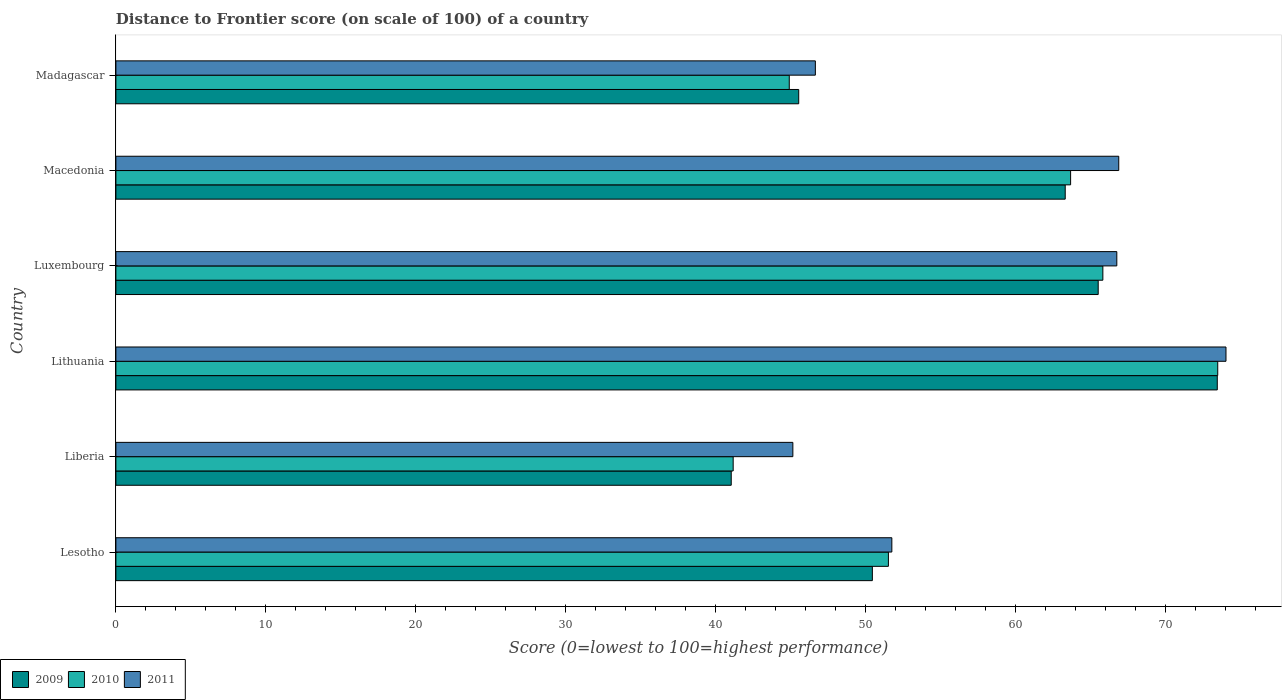Are the number of bars on each tick of the Y-axis equal?
Provide a succinct answer. Yes. What is the label of the 6th group of bars from the top?
Provide a succinct answer. Lesotho. In how many cases, is the number of bars for a given country not equal to the number of legend labels?
Offer a very short reply. 0. What is the distance to frontier score of in 2009 in Luxembourg?
Offer a terse response. 65.5. Across all countries, what is the maximum distance to frontier score of in 2009?
Provide a short and direct response. 73.44. Across all countries, what is the minimum distance to frontier score of in 2010?
Your answer should be very brief. 41.16. In which country was the distance to frontier score of in 2011 maximum?
Provide a short and direct response. Lithuania. In which country was the distance to frontier score of in 2011 minimum?
Ensure brevity in your answer.  Liberia. What is the total distance to frontier score of in 2010 in the graph?
Ensure brevity in your answer.  340.51. What is the difference between the distance to frontier score of in 2010 in Luxembourg and that in Macedonia?
Give a very brief answer. 2.15. What is the difference between the distance to frontier score of in 2009 in Liberia and the distance to frontier score of in 2010 in Madagascar?
Provide a short and direct response. -3.87. What is the average distance to frontier score of in 2010 per country?
Provide a short and direct response. 56.75. What is the difference between the distance to frontier score of in 2010 and distance to frontier score of in 2009 in Luxembourg?
Your answer should be compact. 0.31. In how many countries, is the distance to frontier score of in 2011 greater than 12 ?
Offer a very short reply. 6. What is the ratio of the distance to frontier score of in 2010 in Lesotho to that in Madagascar?
Your answer should be very brief. 1.15. Is the distance to frontier score of in 2011 in Liberia less than that in Lithuania?
Offer a terse response. Yes. Is the difference between the distance to frontier score of in 2010 in Luxembourg and Madagascar greater than the difference between the distance to frontier score of in 2009 in Luxembourg and Madagascar?
Your answer should be compact. Yes. What is the difference between the highest and the second highest distance to frontier score of in 2011?
Your response must be concise. 7.15. What is the difference between the highest and the lowest distance to frontier score of in 2011?
Offer a terse response. 28.88. In how many countries, is the distance to frontier score of in 2011 greater than the average distance to frontier score of in 2011 taken over all countries?
Your answer should be very brief. 3. Is the sum of the distance to frontier score of in 2011 in Liberia and Madagascar greater than the maximum distance to frontier score of in 2009 across all countries?
Make the answer very short. Yes. What does the 2nd bar from the bottom in Lesotho represents?
Provide a succinct answer. 2010. Is it the case that in every country, the sum of the distance to frontier score of in 2010 and distance to frontier score of in 2009 is greater than the distance to frontier score of in 2011?
Your answer should be very brief. Yes. How many bars are there?
Your response must be concise. 18. Are all the bars in the graph horizontal?
Offer a very short reply. Yes. How many countries are there in the graph?
Your answer should be very brief. 6. What is the difference between two consecutive major ticks on the X-axis?
Provide a short and direct response. 10. Are the values on the major ticks of X-axis written in scientific E-notation?
Ensure brevity in your answer.  No. Does the graph contain any zero values?
Your answer should be compact. No. How many legend labels are there?
Provide a short and direct response. 3. What is the title of the graph?
Offer a terse response. Distance to Frontier score (on scale of 100) of a country. What is the label or title of the X-axis?
Your answer should be compact. Score (0=lowest to 100=highest performance). What is the Score (0=lowest to 100=highest performance) of 2009 in Lesotho?
Your answer should be very brief. 50.44. What is the Score (0=lowest to 100=highest performance) of 2010 in Lesotho?
Offer a very short reply. 51.51. What is the Score (0=lowest to 100=highest performance) in 2011 in Lesotho?
Provide a short and direct response. 51.74. What is the Score (0=lowest to 100=highest performance) of 2009 in Liberia?
Give a very brief answer. 41.03. What is the Score (0=lowest to 100=highest performance) in 2010 in Liberia?
Provide a short and direct response. 41.16. What is the Score (0=lowest to 100=highest performance) in 2011 in Liberia?
Offer a terse response. 45.14. What is the Score (0=lowest to 100=highest performance) of 2009 in Lithuania?
Your response must be concise. 73.44. What is the Score (0=lowest to 100=highest performance) in 2010 in Lithuania?
Provide a short and direct response. 73.47. What is the Score (0=lowest to 100=highest performance) of 2011 in Lithuania?
Keep it short and to the point. 74.02. What is the Score (0=lowest to 100=highest performance) in 2009 in Luxembourg?
Provide a short and direct response. 65.5. What is the Score (0=lowest to 100=highest performance) in 2010 in Luxembourg?
Offer a very short reply. 65.81. What is the Score (0=lowest to 100=highest performance) of 2011 in Luxembourg?
Provide a short and direct response. 66.74. What is the Score (0=lowest to 100=highest performance) of 2009 in Macedonia?
Make the answer very short. 63.3. What is the Score (0=lowest to 100=highest performance) in 2010 in Macedonia?
Provide a succinct answer. 63.66. What is the Score (0=lowest to 100=highest performance) of 2011 in Macedonia?
Your answer should be very brief. 66.87. What is the Score (0=lowest to 100=highest performance) in 2009 in Madagascar?
Your answer should be compact. 45.53. What is the Score (0=lowest to 100=highest performance) in 2010 in Madagascar?
Offer a very short reply. 44.9. What is the Score (0=lowest to 100=highest performance) in 2011 in Madagascar?
Provide a succinct answer. 46.64. Across all countries, what is the maximum Score (0=lowest to 100=highest performance) of 2009?
Offer a very short reply. 73.44. Across all countries, what is the maximum Score (0=lowest to 100=highest performance) in 2010?
Offer a very short reply. 73.47. Across all countries, what is the maximum Score (0=lowest to 100=highest performance) in 2011?
Offer a terse response. 74.02. Across all countries, what is the minimum Score (0=lowest to 100=highest performance) in 2009?
Your answer should be very brief. 41.03. Across all countries, what is the minimum Score (0=lowest to 100=highest performance) in 2010?
Offer a very short reply. 41.16. Across all countries, what is the minimum Score (0=lowest to 100=highest performance) of 2011?
Your answer should be compact. 45.14. What is the total Score (0=lowest to 100=highest performance) in 2009 in the graph?
Your response must be concise. 339.24. What is the total Score (0=lowest to 100=highest performance) of 2010 in the graph?
Offer a terse response. 340.51. What is the total Score (0=lowest to 100=highest performance) of 2011 in the graph?
Give a very brief answer. 351.15. What is the difference between the Score (0=lowest to 100=highest performance) of 2009 in Lesotho and that in Liberia?
Offer a terse response. 9.41. What is the difference between the Score (0=lowest to 100=highest performance) in 2010 in Lesotho and that in Liberia?
Make the answer very short. 10.35. What is the difference between the Score (0=lowest to 100=highest performance) of 2011 in Lesotho and that in Liberia?
Keep it short and to the point. 6.6. What is the difference between the Score (0=lowest to 100=highest performance) in 2010 in Lesotho and that in Lithuania?
Your response must be concise. -21.96. What is the difference between the Score (0=lowest to 100=highest performance) in 2011 in Lesotho and that in Lithuania?
Provide a short and direct response. -22.28. What is the difference between the Score (0=lowest to 100=highest performance) of 2009 in Lesotho and that in Luxembourg?
Your answer should be compact. -15.06. What is the difference between the Score (0=lowest to 100=highest performance) of 2010 in Lesotho and that in Luxembourg?
Give a very brief answer. -14.3. What is the difference between the Score (0=lowest to 100=highest performance) in 2009 in Lesotho and that in Macedonia?
Your answer should be compact. -12.86. What is the difference between the Score (0=lowest to 100=highest performance) in 2010 in Lesotho and that in Macedonia?
Your answer should be compact. -12.15. What is the difference between the Score (0=lowest to 100=highest performance) in 2011 in Lesotho and that in Macedonia?
Make the answer very short. -15.13. What is the difference between the Score (0=lowest to 100=highest performance) of 2009 in Lesotho and that in Madagascar?
Ensure brevity in your answer.  4.91. What is the difference between the Score (0=lowest to 100=highest performance) in 2010 in Lesotho and that in Madagascar?
Ensure brevity in your answer.  6.61. What is the difference between the Score (0=lowest to 100=highest performance) in 2011 in Lesotho and that in Madagascar?
Ensure brevity in your answer.  5.1. What is the difference between the Score (0=lowest to 100=highest performance) of 2009 in Liberia and that in Lithuania?
Provide a short and direct response. -32.41. What is the difference between the Score (0=lowest to 100=highest performance) of 2010 in Liberia and that in Lithuania?
Keep it short and to the point. -32.31. What is the difference between the Score (0=lowest to 100=highest performance) in 2011 in Liberia and that in Lithuania?
Keep it short and to the point. -28.88. What is the difference between the Score (0=lowest to 100=highest performance) of 2009 in Liberia and that in Luxembourg?
Your answer should be compact. -24.47. What is the difference between the Score (0=lowest to 100=highest performance) in 2010 in Liberia and that in Luxembourg?
Make the answer very short. -24.65. What is the difference between the Score (0=lowest to 100=highest performance) of 2011 in Liberia and that in Luxembourg?
Provide a succinct answer. -21.6. What is the difference between the Score (0=lowest to 100=highest performance) of 2009 in Liberia and that in Macedonia?
Your answer should be very brief. -22.27. What is the difference between the Score (0=lowest to 100=highest performance) of 2010 in Liberia and that in Macedonia?
Offer a very short reply. -22.5. What is the difference between the Score (0=lowest to 100=highest performance) in 2011 in Liberia and that in Macedonia?
Offer a terse response. -21.73. What is the difference between the Score (0=lowest to 100=highest performance) of 2010 in Liberia and that in Madagascar?
Ensure brevity in your answer.  -3.74. What is the difference between the Score (0=lowest to 100=highest performance) of 2011 in Liberia and that in Madagascar?
Your response must be concise. -1.5. What is the difference between the Score (0=lowest to 100=highest performance) in 2009 in Lithuania and that in Luxembourg?
Give a very brief answer. 7.94. What is the difference between the Score (0=lowest to 100=highest performance) of 2010 in Lithuania and that in Luxembourg?
Keep it short and to the point. 7.66. What is the difference between the Score (0=lowest to 100=highest performance) in 2011 in Lithuania and that in Luxembourg?
Ensure brevity in your answer.  7.28. What is the difference between the Score (0=lowest to 100=highest performance) in 2009 in Lithuania and that in Macedonia?
Your answer should be compact. 10.14. What is the difference between the Score (0=lowest to 100=highest performance) of 2010 in Lithuania and that in Macedonia?
Ensure brevity in your answer.  9.81. What is the difference between the Score (0=lowest to 100=highest performance) in 2011 in Lithuania and that in Macedonia?
Your answer should be compact. 7.15. What is the difference between the Score (0=lowest to 100=highest performance) of 2009 in Lithuania and that in Madagascar?
Provide a short and direct response. 27.91. What is the difference between the Score (0=lowest to 100=highest performance) of 2010 in Lithuania and that in Madagascar?
Give a very brief answer. 28.57. What is the difference between the Score (0=lowest to 100=highest performance) of 2011 in Lithuania and that in Madagascar?
Keep it short and to the point. 27.38. What is the difference between the Score (0=lowest to 100=highest performance) in 2010 in Luxembourg and that in Macedonia?
Your response must be concise. 2.15. What is the difference between the Score (0=lowest to 100=highest performance) in 2011 in Luxembourg and that in Macedonia?
Ensure brevity in your answer.  -0.13. What is the difference between the Score (0=lowest to 100=highest performance) in 2009 in Luxembourg and that in Madagascar?
Your response must be concise. 19.97. What is the difference between the Score (0=lowest to 100=highest performance) of 2010 in Luxembourg and that in Madagascar?
Provide a short and direct response. 20.91. What is the difference between the Score (0=lowest to 100=highest performance) of 2011 in Luxembourg and that in Madagascar?
Ensure brevity in your answer.  20.1. What is the difference between the Score (0=lowest to 100=highest performance) of 2009 in Macedonia and that in Madagascar?
Give a very brief answer. 17.77. What is the difference between the Score (0=lowest to 100=highest performance) in 2010 in Macedonia and that in Madagascar?
Give a very brief answer. 18.76. What is the difference between the Score (0=lowest to 100=highest performance) of 2011 in Macedonia and that in Madagascar?
Your answer should be very brief. 20.23. What is the difference between the Score (0=lowest to 100=highest performance) of 2009 in Lesotho and the Score (0=lowest to 100=highest performance) of 2010 in Liberia?
Ensure brevity in your answer.  9.28. What is the difference between the Score (0=lowest to 100=highest performance) of 2010 in Lesotho and the Score (0=lowest to 100=highest performance) of 2011 in Liberia?
Offer a terse response. 6.37. What is the difference between the Score (0=lowest to 100=highest performance) of 2009 in Lesotho and the Score (0=lowest to 100=highest performance) of 2010 in Lithuania?
Provide a short and direct response. -23.03. What is the difference between the Score (0=lowest to 100=highest performance) of 2009 in Lesotho and the Score (0=lowest to 100=highest performance) of 2011 in Lithuania?
Offer a very short reply. -23.58. What is the difference between the Score (0=lowest to 100=highest performance) in 2010 in Lesotho and the Score (0=lowest to 100=highest performance) in 2011 in Lithuania?
Your answer should be compact. -22.51. What is the difference between the Score (0=lowest to 100=highest performance) in 2009 in Lesotho and the Score (0=lowest to 100=highest performance) in 2010 in Luxembourg?
Your answer should be very brief. -15.37. What is the difference between the Score (0=lowest to 100=highest performance) of 2009 in Lesotho and the Score (0=lowest to 100=highest performance) of 2011 in Luxembourg?
Give a very brief answer. -16.3. What is the difference between the Score (0=lowest to 100=highest performance) of 2010 in Lesotho and the Score (0=lowest to 100=highest performance) of 2011 in Luxembourg?
Your answer should be very brief. -15.23. What is the difference between the Score (0=lowest to 100=highest performance) in 2009 in Lesotho and the Score (0=lowest to 100=highest performance) in 2010 in Macedonia?
Your answer should be compact. -13.22. What is the difference between the Score (0=lowest to 100=highest performance) of 2009 in Lesotho and the Score (0=lowest to 100=highest performance) of 2011 in Macedonia?
Your answer should be compact. -16.43. What is the difference between the Score (0=lowest to 100=highest performance) of 2010 in Lesotho and the Score (0=lowest to 100=highest performance) of 2011 in Macedonia?
Your answer should be compact. -15.36. What is the difference between the Score (0=lowest to 100=highest performance) in 2009 in Lesotho and the Score (0=lowest to 100=highest performance) in 2010 in Madagascar?
Make the answer very short. 5.54. What is the difference between the Score (0=lowest to 100=highest performance) in 2010 in Lesotho and the Score (0=lowest to 100=highest performance) in 2011 in Madagascar?
Your answer should be very brief. 4.87. What is the difference between the Score (0=lowest to 100=highest performance) in 2009 in Liberia and the Score (0=lowest to 100=highest performance) in 2010 in Lithuania?
Offer a very short reply. -32.44. What is the difference between the Score (0=lowest to 100=highest performance) of 2009 in Liberia and the Score (0=lowest to 100=highest performance) of 2011 in Lithuania?
Keep it short and to the point. -32.99. What is the difference between the Score (0=lowest to 100=highest performance) in 2010 in Liberia and the Score (0=lowest to 100=highest performance) in 2011 in Lithuania?
Your response must be concise. -32.86. What is the difference between the Score (0=lowest to 100=highest performance) of 2009 in Liberia and the Score (0=lowest to 100=highest performance) of 2010 in Luxembourg?
Your response must be concise. -24.78. What is the difference between the Score (0=lowest to 100=highest performance) in 2009 in Liberia and the Score (0=lowest to 100=highest performance) in 2011 in Luxembourg?
Your response must be concise. -25.71. What is the difference between the Score (0=lowest to 100=highest performance) of 2010 in Liberia and the Score (0=lowest to 100=highest performance) of 2011 in Luxembourg?
Give a very brief answer. -25.58. What is the difference between the Score (0=lowest to 100=highest performance) of 2009 in Liberia and the Score (0=lowest to 100=highest performance) of 2010 in Macedonia?
Provide a succinct answer. -22.63. What is the difference between the Score (0=lowest to 100=highest performance) in 2009 in Liberia and the Score (0=lowest to 100=highest performance) in 2011 in Macedonia?
Make the answer very short. -25.84. What is the difference between the Score (0=lowest to 100=highest performance) in 2010 in Liberia and the Score (0=lowest to 100=highest performance) in 2011 in Macedonia?
Make the answer very short. -25.71. What is the difference between the Score (0=lowest to 100=highest performance) in 2009 in Liberia and the Score (0=lowest to 100=highest performance) in 2010 in Madagascar?
Offer a terse response. -3.87. What is the difference between the Score (0=lowest to 100=highest performance) of 2009 in Liberia and the Score (0=lowest to 100=highest performance) of 2011 in Madagascar?
Your response must be concise. -5.61. What is the difference between the Score (0=lowest to 100=highest performance) of 2010 in Liberia and the Score (0=lowest to 100=highest performance) of 2011 in Madagascar?
Offer a terse response. -5.48. What is the difference between the Score (0=lowest to 100=highest performance) of 2009 in Lithuania and the Score (0=lowest to 100=highest performance) of 2010 in Luxembourg?
Provide a short and direct response. 7.63. What is the difference between the Score (0=lowest to 100=highest performance) of 2009 in Lithuania and the Score (0=lowest to 100=highest performance) of 2011 in Luxembourg?
Keep it short and to the point. 6.7. What is the difference between the Score (0=lowest to 100=highest performance) in 2010 in Lithuania and the Score (0=lowest to 100=highest performance) in 2011 in Luxembourg?
Your answer should be compact. 6.73. What is the difference between the Score (0=lowest to 100=highest performance) in 2009 in Lithuania and the Score (0=lowest to 100=highest performance) in 2010 in Macedonia?
Your answer should be compact. 9.78. What is the difference between the Score (0=lowest to 100=highest performance) of 2009 in Lithuania and the Score (0=lowest to 100=highest performance) of 2011 in Macedonia?
Ensure brevity in your answer.  6.57. What is the difference between the Score (0=lowest to 100=highest performance) of 2009 in Lithuania and the Score (0=lowest to 100=highest performance) of 2010 in Madagascar?
Make the answer very short. 28.54. What is the difference between the Score (0=lowest to 100=highest performance) in 2009 in Lithuania and the Score (0=lowest to 100=highest performance) in 2011 in Madagascar?
Your answer should be compact. 26.8. What is the difference between the Score (0=lowest to 100=highest performance) in 2010 in Lithuania and the Score (0=lowest to 100=highest performance) in 2011 in Madagascar?
Offer a terse response. 26.83. What is the difference between the Score (0=lowest to 100=highest performance) of 2009 in Luxembourg and the Score (0=lowest to 100=highest performance) of 2010 in Macedonia?
Keep it short and to the point. 1.84. What is the difference between the Score (0=lowest to 100=highest performance) in 2009 in Luxembourg and the Score (0=lowest to 100=highest performance) in 2011 in Macedonia?
Keep it short and to the point. -1.37. What is the difference between the Score (0=lowest to 100=highest performance) of 2010 in Luxembourg and the Score (0=lowest to 100=highest performance) of 2011 in Macedonia?
Offer a very short reply. -1.06. What is the difference between the Score (0=lowest to 100=highest performance) of 2009 in Luxembourg and the Score (0=lowest to 100=highest performance) of 2010 in Madagascar?
Make the answer very short. 20.6. What is the difference between the Score (0=lowest to 100=highest performance) of 2009 in Luxembourg and the Score (0=lowest to 100=highest performance) of 2011 in Madagascar?
Provide a succinct answer. 18.86. What is the difference between the Score (0=lowest to 100=highest performance) in 2010 in Luxembourg and the Score (0=lowest to 100=highest performance) in 2011 in Madagascar?
Provide a short and direct response. 19.17. What is the difference between the Score (0=lowest to 100=highest performance) of 2009 in Macedonia and the Score (0=lowest to 100=highest performance) of 2010 in Madagascar?
Your response must be concise. 18.4. What is the difference between the Score (0=lowest to 100=highest performance) in 2009 in Macedonia and the Score (0=lowest to 100=highest performance) in 2011 in Madagascar?
Keep it short and to the point. 16.66. What is the difference between the Score (0=lowest to 100=highest performance) of 2010 in Macedonia and the Score (0=lowest to 100=highest performance) of 2011 in Madagascar?
Provide a succinct answer. 17.02. What is the average Score (0=lowest to 100=highest performance) in 2009 per country?
Keep it short and to the point. 56.54. What is the average Score (0=lowest to 100=highest performance) of 2010 per country?
Keep it short and to the point. 56.75. What is the average Score (0=lowest to 100=highest performance) of 2011 per country?
Give a very brief answer. 58.52. What is the difference between the Score (0=lowest to 100=highest performance) of 2009 and Score (0=lowest to 100=highest performance) of 2010 in Lesotho?
Keep it short and to the point. -1.07. What is the difference between the Score (0=lowest to 100=highest performance) of 2010 and Score (0=lowest to 100=highest performance) of 2011 in Lesotho?
Give a very brief answer. -0.23. What is the difference between the Score (0=lowest to 100=highest performance) in 2009 and Score (0=lowest to 100=highest performance) in 2010 in Liberia?
Offer a terse response. -0.13. What is the difference between the Score (0=lowest to 100=highest performance) of 2009 and Score (0=lowest to 100=highest performance) of 2011 in Liberia?
Provide a succinct answer. -4.11. What is the difference between the Score (0=lowest to 100=highest performance) of 2010 and Score (0=lowest to 100=highest performance) of 2011 in Liberia?
Make the answer very short. -3.98. What is the difference between the Score (0=lowest to 100=highest performance) of 2009 and Score (0=lowest to 100=highest performance) of 2010 in Lithuania?
Ensure brevity in your answer.  -0.03. What is the difference between the Score (0=lowest to 100=highest performance) in 2009 and Score (0=lowest to 100=highest performance) in 2011 in Lithuania?
Offer a terse response. -0.58. What is the difference between the Score (0=lowest to 100=highest performance) in 2010 and Score (0=lowest to 100=highest performance) in 2011 in Lithuania?
Keep it short and to the point. -0.55. What is the difference between the Score (0=lowest to 100=highest performance) in 2009 and Score (0=lowest to 100=highest performance) in 2010 in Luxembourg?
Your answer should be compact. -0.31. What is the difference between the Score (0=lowest to 100=highest performance) of 2009 and Score (0=lowest to 100=highest performance) of 2011 in Luxembourg?
Provide a succinct answer. -1.24. What is the difference between the Score (0=lowest to 100=highest performance) of 2010 and Score (0=lowest to 100=highest performance) of 2011 in Luxembourg?
Make the answer very short. -0.93. What is the difference between the Score (0=lowest to 100=highest performance) in 2009 and Score (0=lowest to 100=highest performance) in 2010 in Macedonia?
Ensure brevity in your answer.  -0.36. What is the difference between the Score (0=lowest to 100=highest performance) in 2009 and Score (0=lowest to 100=highest performance) in 2011 in Macedonia?
Make the answer very short. -3.57. What is the difference between the Score (0=lowest to 100=highest performance) in 2010 and Score (0=lowest to 100=highest performance) in 2011 in Macedonia?
Offer a very short reply. -3.21. What is the difference between the Score (0=lowest to 100=highest performance) of 2009 and Score (0=lowest to 100=highest performance) of 2010 in Madagascar?
Your answer should be compact. 0.63. What is the difference between the Score (0=lowest to 100=highest performance) of 2009 and Score (0=lowest to 100=highest performance) of 2011 in Madagascar?
Your answer should be very brief. -1.11. What is the difference between the Score (0=lowest to 100=highest performance) in 2010 and Score (0=lowest to 100=highest performance) in 2011 in Madagascar?
Provide a short and direct response. -1.74. What is the ratio of the Score (0=lowest to 100=highest performance) of 2009 in Lesotho to that in Liberia?
Your answer should be compact. 1.23. What is the ratio of the Score (0=lowest to 100=highest performance) in 2010 in Lesotho to that in Liberia?
Keep it short and to the point. 1.25. What is the ratio of the Score (0=lowest to 100=highest performance) in 2011 in Lesotho to that in Liberia?
Offer a terse response. 1.15. What is the ratio of the Score (0=lowest to 100=highest performance) in 2009 in Lesotho to that in Lithuania?
Ensure brevity in your answer.  0.69. What is the ratio of the Score (0=lowest to 100=highest performance) in 2010 in Lesotho to that in Lithuania?
Provide a short and direct response. 0.7. What is the ratio of the Score (0=lowest to 100=highest performance) of 2011 in Lesotho to that in Lithuania?
Provide a short and direct response. 0.7. What is the ratio of the Score (0=lowest to 100=highest performance) of 2009 in Lesotho to that in Luxembourg?
Provide a succinct answer. 0.77. What is the ratio of the Score (0=lowest to 100=highest performance) of 2010 in Lesotho to that in Luxembourg?
Keep it short and to the point. 0.78. What is the ratio of the Score (0=lowest to 100=highest performance) of 2011 in Lesotho to that in Luxembourg?
Your response must be concise. 0.78. What is the ratio of the Score (0=lowest to 100=highest performance) in 2009 in Lesotho to that in Macedonia?
Offer a terse response. 0.8. What is the ratio of the Score (0=lowest to 100=highest performance) of 2010 in Lesotho to that in Macedonia?
Offer a very short reply. 0.81. What is the ratio of the Score (0=lowest to 100=highest performance) of 2011 in Lesotho to that in Macedonia?
Make the answer very short. 0.77. What is the ratio of the Score (0=lowest to 100=highest performance) of 2009 in Lesotho to that in Madagascar?
Keep it short and to the point. 1.11. What is the ratio of the Score (0=lowest to 100=highest performance) in 2010 in Lesotho to that in Madagascar?
Offer a very short reply. 1.15. What is the ratio of the Score (0=lowest to 100=highest performance) in 2011 in Lesotho to that in Madagascar?
Keep it short and to the point. 1.11. What is the ratio of the Score (0=lowest to 100=highest performance) in 2009 in Liberia to that in Lithuania?
Provide a short and direct response. 0.56. What is the ratio of the Score (0=lowest to 100=highest performance) in 2010 in Liberia to that in Lithuania?
Your answer should be very brief. 0.56. What is the ratio of the Score (0=lowest to 100=highest performance) of 2011 in Liberia to that in Lithuania?
Ensure brevity in your answer.  0.61. What is the ratio of the Score (0=lowest to 100=highest performance) in 2009 in Liberia to that in Luxembourg?
Your answer should be compact. 0.63. What is the ratio of the Score (0=lowest to 100=highest performance) in 2010 in Liberia to that in Luxembourg?
Your answer should be compact. 0.63. What is the ratio of the Score (0=lowest to 100=highest performance) in 2011 in Liberia to that in Luxembourg?
Give a very brief answer. 0.68. What is the ratio of the Score (0=lowest to 100=highest performance) in 2009 in Liberia to that in Macedonia?
Your answer should be very brief. 0.65. What is the ratio of the Score (0=lowest to 100=highest performance) of 2010 in Liberia to that in Macedonia?
Provide a succinct answer. 0.65. What is the ratio of the Score (0=lowest to 100=highest performance) of 2011 in Liberia to that in Macedonia?
Offer a very short reply. 0.68. What is the ratio of the Score (0=lowest to 100=highest performance) of 2009 in Liberia to that in Madagascar?
Your response must be concise. 0.9. What is the ratio of the Score (0=lowest to 100=highest performance) in 2011 in Liberia to that in Madagascar?
Provide a short and direct response. 0.97. What is the ratio of the Score (0=lowest to 100=highest performance) of 2009 in Lithuania to that in Luxembourg?
Provide a short and direct response. 1.12. What is the ratio of the Score (0=lowest to 100=highest performance) of 2010 in Lithuania to that in Luxembourg?
Your answer should be very brief. 1.12. What is the ratio of the Score (0=lowest to 100=highest performance) in 2011 in Lithuania to that in Luxembourg?
Offer a very short reply. 1.11. What is the ratio of the Score (0=lowest to 100=highest performance) in 2009 in Lithuania to that in Macedonia?
Provide a succinct answer. 1.16. What is the ratio of the Score (0=lowest to 100=highest performance) in 2010 in Lithuania to that in Macedonia?
Your answer should be very brief. 1.15. What is the ratio of the Score (0=lowest to 100=highest performance) of 2011 in Lithuania to that in Macedonia?
Offer a very short reply. 1.11. What is the ratio of the Score (0=lowest to 100=highest performance) in 2009 in Lithuania to that in Madagascar?
Give a very brief answer. 1.61. What is the ratio of the Score (0=lowest to 100=highest performance) in 2010 in Lithuania to that in Madagascar?
Make the answer very short. 1.64. What is the ratio of the Score (0=lowest to 100=highest performance) of 2011 in Lithuania to that in Madagascar?
Provide a succinct answer. 1.59. What is the ratio of the Score (0=lowest to 100=highest performance) of 2009 in Luxembourg to that in Macedonia?
Your answer should be very brief. 1.03. What is the ratio of the Score (0=lowest to 100=highest performance) in 2010 in Luxembourg to that in Macedonia?
Offer a terse response. 1.03. What is the ratio of the Score (0=lowest to 100=highest performance) of 2009 in Luxembourg to that in Madagascar?
Provide a succinct answer. 1.44. What is the ratio of the Score (0=lowest to 100=highest performance) in 2010 in Luxembourg to that in Madagascar?
Your response must be concise. 1.47. What is the ratio of the Score (0=lowest to 100=highest performance) of 2011 in Luxembourg to that in Madagascar?
Provide a short and direct response. 1.43. What is the ratio of the Score (0=lowest to 100=highest performance) of 2009 in Macedonia to that in Madagascar?
Make the answer very short. 1.39. What is the ratio of the Score (0=lowest to 100=highest performance) of 2010 in Macedonia to that in Madagascar?
Make the answer very short. 1.42. What is the ratio of the Score (0=lowest to 100=highest performance) in 2011 in Macedonia to that in Madagascar?
Keep it short and to the point. 1.43. What is the difference between the highest and the second highest Score (0=lowest to 100=highest performance) of 2009?
Provide a succinct answer. 7.94. What is the difference between the highest and the second highest Score (0=lowest to 100=highest performance) of 2010?
Offer a very short reply. 7.66. What is the difference between the highest and the second highest Score (0=lowest to 100=highest performance) of 2011?
Your response must be concise. 7.15. What is the difference between the highest and the lowest Score (0=lowest to 100=highest performance) in 2009?
Provide a succinct answer. 32.41. What is the difference between the highest and the lowest Score (0=lowest to 100=highest performance) in 2010?
Offer a very short reply. 32.31. What is the difference between the highest and the lowest Score (0=lowest to 100=highest performance) of 2011?
Your response must be concise. 28.88. 